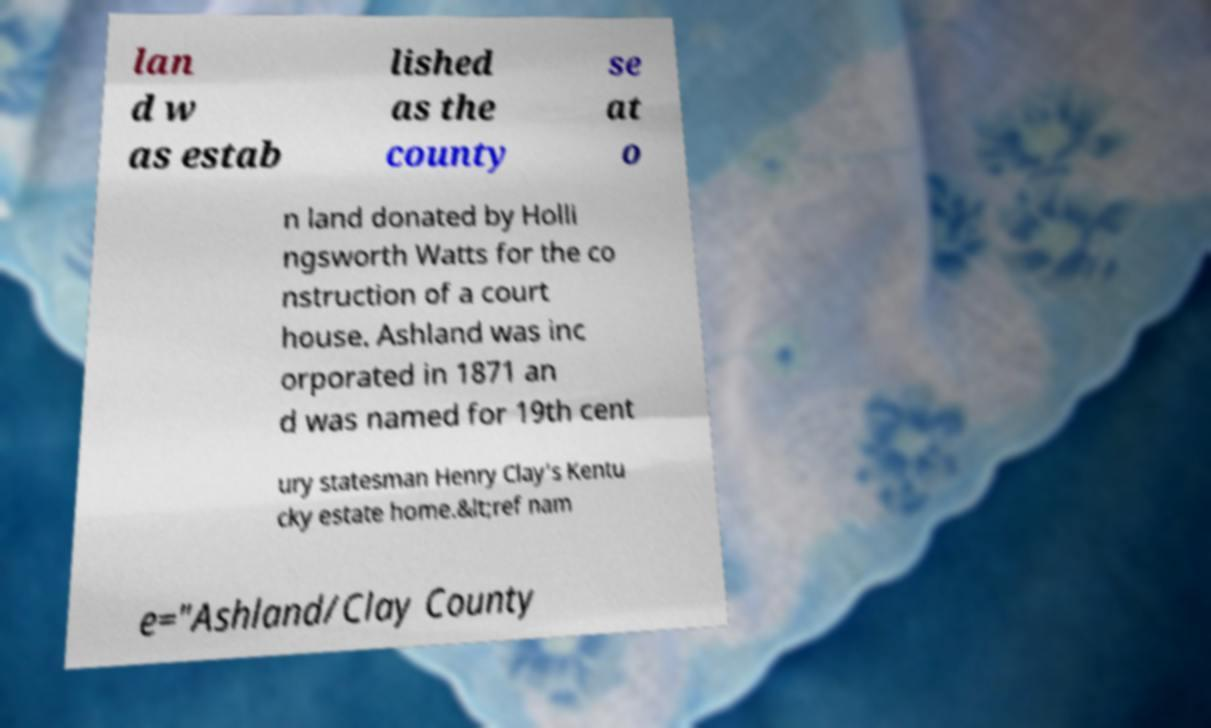Could you assist in decoding the text presented in this image and type it out clearly? lan d w as estab lished as the county se at o n land donated by Holli ngsworth Watts for the co nstruction of a court house. Ashland was inc orporated in 1871 an d was named for 19th cent ury statesman Henry Clay's Kentu cky estate home.&lt;ref nam e="Ashland/Clay County 